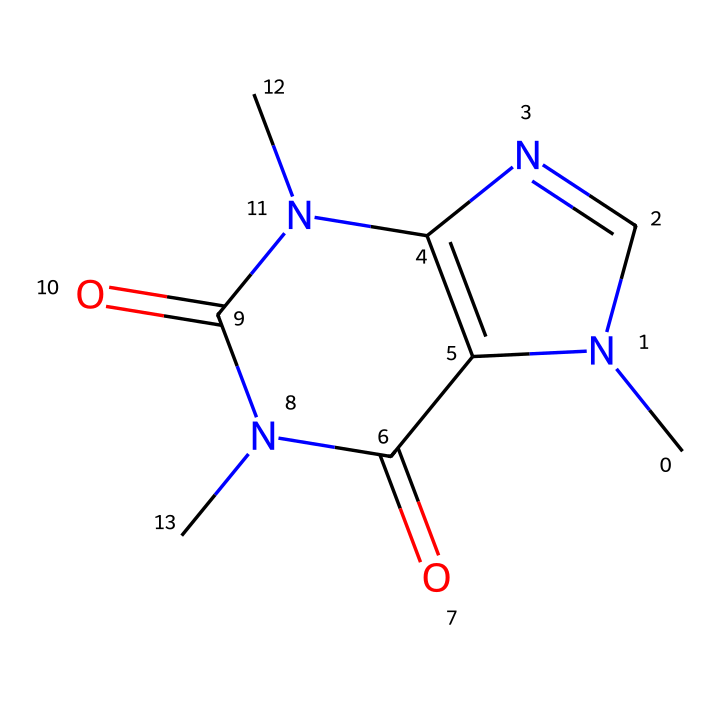How many nitrogen atoms are in the caffeine molecule? The SMILES representation shows two distinct nitrogen atoms represented as "N". Counting these, we find that there are exactly four instances of nitrogen in the structure.
Answer: four What is the molecular formula of caffeine? From the chemical structure, we can deduce the atoms present: there are 8 carbon atoms (C), 10 hydrogen atoms (H), 4 nitrogen atoms (N), and 2 oxygen atoms (O). Thus, the molecular formula is C8H10N4O2.
Answer: C8H10N4O2 Is caffeine a soluble substance? Caffeine is known to be water-soluble since it is a non-electrolyte molecule due to its non-ionic nature, promoting its dissolution in polar solvents.
Answer: soluble How does caffeine's nitrogen structure contribute to its biological activity? The presence of multiple nitrogen atoms (specifically in a ring and functional groups) facilitates the formation of hydrogen bonds and its ability to interact with neurotransmitter receptors, thereby impacting its stimulatory effects on the nervous system.
Answer: hydrogen bonds What type of non-electrolyte is caffeine classified as? Caffeine belongs to the class of non-electrolytes known as alkaloids, characterized by their basic properties and presence of nitrogen atoms, which generally affect plant metabolism.
Answer: alkaloid What functional group is present in caffeine's structure? The presence of carbonyl groups (=O) in the structure, which are indicative of amide functionalities, plays a significant role in its solubility and biological activity.
Answer: carbonyl groups 